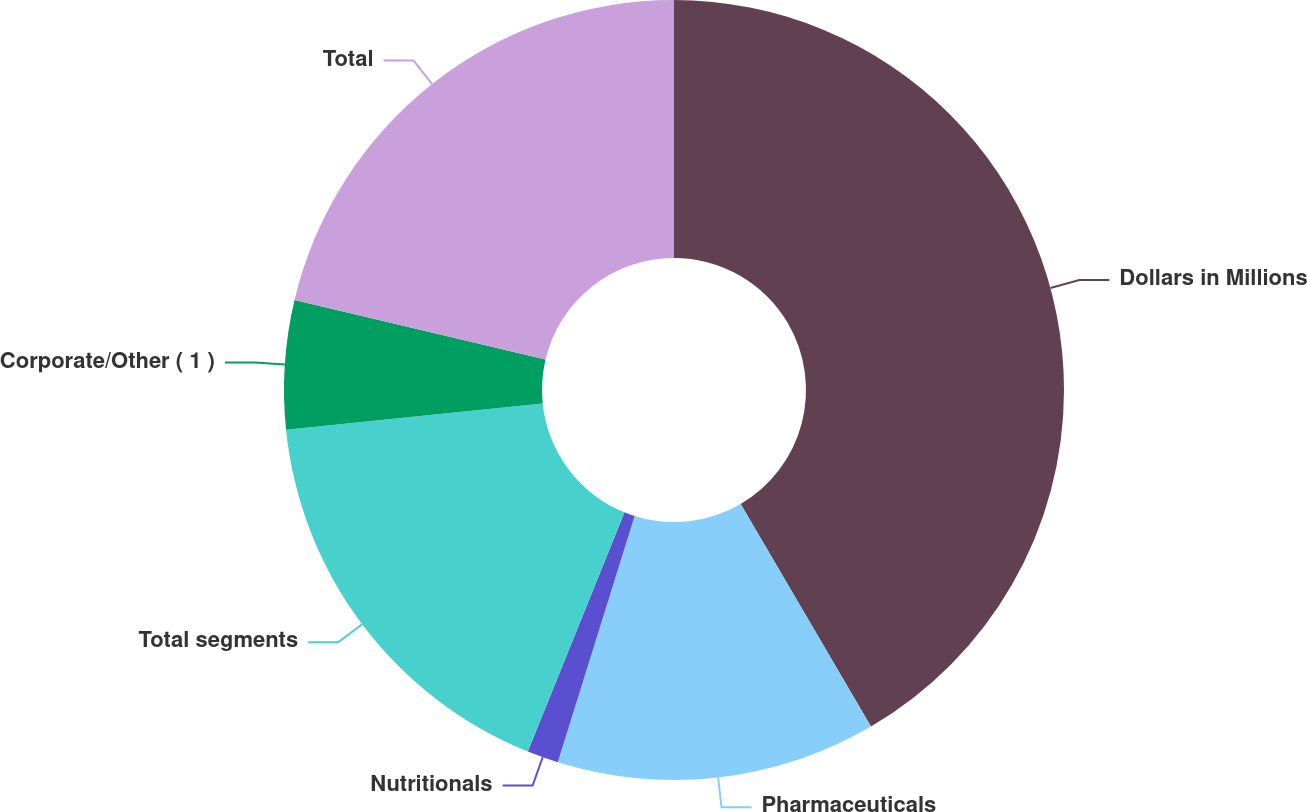Convert chart to OTSL. <chart><loc_0><loc_0><loc_500><loc_500><pie_chart><fcel>Dollars in Millions<fcel>Pharmaceuticals<fcel>Nutritionals<fcel>Total segments<fcel>Corporate/Other ( 1 )<fcel>Total<nl><fcel>41.57%<fcel>13.24%<fcel>1.3%<fcel>17.26%<fcel>5.33%<fcel>21.29%<nl></chart> 